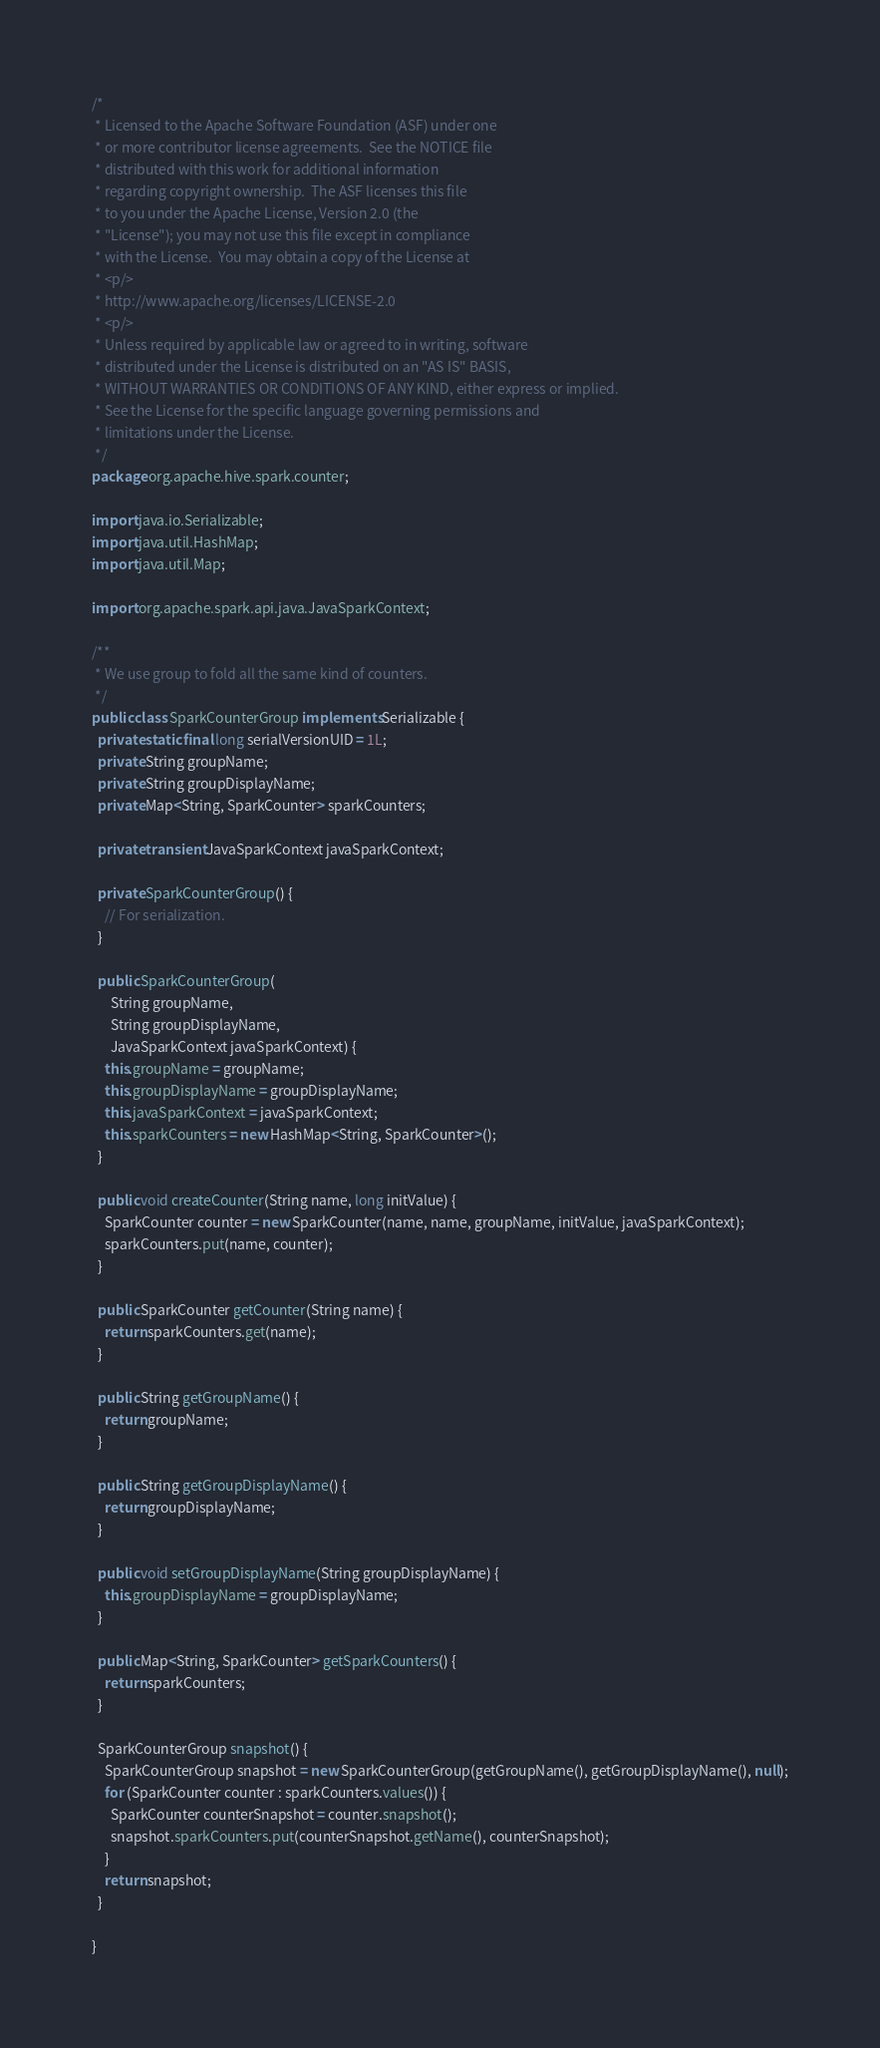<code> <loc_0><loc_0><loc_500><loc_500><_Java_>/*
 * Licensed to the Apache Software Foundation (ASF) under one
 * or more contributor license agreements.  See the NOTICE file
 * distributed with this work for additional information
 * regarding copyright ownership.  The ASF licenses this file
 * to you under the Apache License, Version 2.0 (the
 * "License"); you may not use this file except in compliance
 * with the License.  You may obtain a copy of the License at
 * <p/>
 * http://www.apache.org/licenses/LICENSE-2.0
 * <p/>
 * Unless required by applicable law or agreed to in writing, software
 * distributed under the License is distributed on an "AS IS" BASIS,
 * WITHOUT WARRANTIES OR CONDITIONS OF ANY KIND, either express or implied.
 * See the License for the specific language governing permissions and
 * limitations under the License.
 */
package org.apache.hive.spark.counter;

import java.io.Serializable;
import java.util.HashMap;
import java.util.Map;

import org.apache.spark.api.java.JavaSparkContext;

/**
 * We use group to fold all the same kind of counters.
 */
public class SparkCounterGroup implements Serializable {
  private static final long serialVersionUID = 1L;
  private String groupName;
  private String groupDisplayName;
  private Map<String, SparkCounter> sparkCounters;

  private transient JavaSparkContext javaSparkContext;

  private SparkCounterGroup() {
    // For serialization.
  }

  public SparkCounterGroup(
      String groupName,
      String groupDisplayName,
      JavaSparkContext javaSparkContext) {
    this.groupName = groupName;
    this.groupDisplayName = groupDisplayName;
    this.javaSparkContext = javaSparkContext;
    this.sparkCounters = new HashMap<String, SparkCounter>();
  }

  public void createCounter(String name, long initValue) {
    SparkCounter counter = new SparkCounter(name, name, groupName, initValue, javaSparkContext);
    sparkCounters.put(name, counter);
  }

  public SparkCounter getCounter(String name) {
    return sparkCounters.get(name);
  }

  public String getGroupName() {
    return groupName;
  }

  public String getGroupDisplayName() {
    return groupDisplayName;
  }

  public void setGroupDisplayName(String groupDisplayName) {
    this.groupDisplayName = groupDisplayName;
  }

  public Map<String, SparkCounter> getSparkCounters() {
    return sparkCounters;
  }

  SparkCounterGroup snapshot() {
    SparkCounterGroup snapshot = new SparkCounterGroup(getGroupName(), getGroupDisplayName(), null);
    for (SparkCounter counter : sparkCounters.values()) {
      SparkCounter counterSnapshot = counter.snapshot();
      snapshot.sparkCounters.put(counterSnapshot.getName(), counterSnapshot);
    }
    return snapshot;
  }

}
</code> 